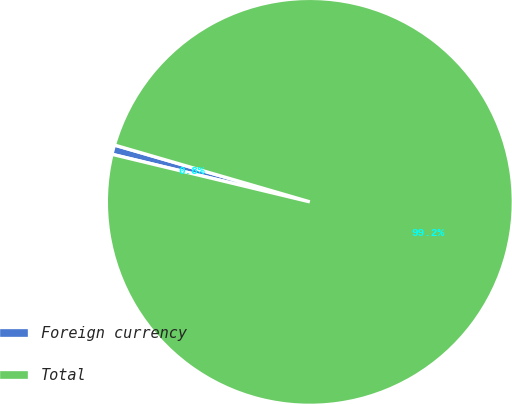<chart> <loc_0><loc_0><loc_500><loc_500><pie_chart><fcel>Foreign currency<fcel>Total<nl><fcel>0.75%<fcel>99.25%<nl></chart> 